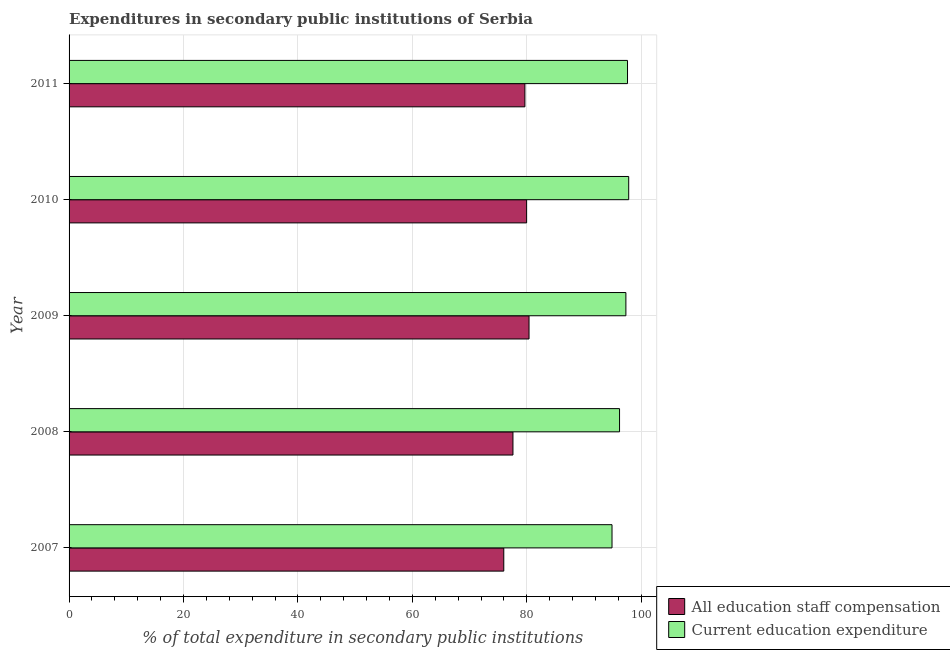How many different coloured bars are there?
Give a very brief answer. 2. How many groups of bars are there?
Ensure brevity in your answer.  5. Are the number of bars on each tick of the Y-axis equal?
Provide a succinct answer. Yes. How many bars are there on the 1st tick from the top?
Provide a short and direct response. 2. How many bars are there on the 4th tick from the bottom?
Offer a terse response. 2. What is the label of the 3rd group of bars from the top?
Offer a very short reply. 2009. What is the expenditure in education in 2011?
Make the answer very short. 97.61. Across all years, what is the maximum expenditure in education?
Provide a succinct answer. 97.81. Across all years, what is the minimum expenditure in education?
Ensure brevity in your answer.  94.9. In which year was the expenditure in education maximum?
Make the answer very short. 2010. What is the total expenditure in education in the graph?
Provide a short and direct response. 483.86. What is the difference between the expenditure in education in 2007 and that in 2008?
Your answer should be compact. -1.32. What is the difference between the expenditure in education in 2008 and the expenditure in staff compensation in 2009?
Your answer should be very brief. 15.82. What is the average expenditure in staff compensation per year?
Offer a terse response. 78.72. In the year 2008, what is the difference between the expenditure in education and expenditure in staff compensation?
Offer a very short reply. 18.63. What is the ratio of the expenditure in education in 2008 to that in 2009?
Your answer should be compact. 0.99. Is the expenditure in staff compensation in 2007 less than that in 2011?
Your answer should be very brief. Yes. Is the difference between the expenditure in staff compensation in 2007 and 2010 greater than the difference between the expenditure in education in 2007 and 2010?
Provide a short and direct response. No. What is the difference between the highest and the second highest expenditure in education?
Offer a terse response. 0.21. What is the difference between the highest and the lowest expenditure in staff compensation?
Make the answer very short. 4.41. What does the 2nd bar from the top in 2007 represents?
Keep it short and to the point. All education staff compensation. What does the 1st bar from the bottom in 2010 represents?
Offer a very short reply. All education staff compensation. Are all the bars in the graph horizontal?
Offer a terse response. Yes. What is the difference between two consecutive major ticks on the X-axis?
Keep it short and to the point. 20. Are the values on the major ticks of X-axis written in scientific E-notation?
Ensure brevity in your answer.  No. Does the graph contain any zero values?
Give a very brief answer. No. Where does the legend appear in the graph?
Your response must be concise. Bottom right. How are the legend labels stacked?
Your answer should be compact. Vertical. What is the title of the graph?
Give a very brief answer. Expenditures in secondary public institutions of Serbia. What is the label or title of the X-axis?
Your response must be concise. % of total expenditure in secondary public institutions. What is the % of total expenditure in secondary public institutions of All education staff compensation in 2007?
Ensure brevity in your answer.  75.98. What is the % of total expenditure in secondary public institutions of Current education expenditure in 2007?
Give a very brief answer. 94.9. What is the % of total expenditure in secondary public institutions in All education staff compensation in 2008?
Give a very brief answer. 77.58. What is the % of total expenditure in secondary public institutions of Current education expenditure in 2008?
Ensure brevity in your answer.  96.22. What is the % of total expenditure in secondary public institutions in All education staff compensation in 2009?
Offer a very short reply. 80.39. What is the % of total expenditure in secondary public institutions in Current education expenditure in 2009?
Give a very brief answer. 97.32. What is the % of total expenditure in secondary public institutions in All education staff compensation in 2010?
Keep it short and to the point. 79.97. What is the % of total expenditure in secondary public institutions of Current education expenditure in 2010?
Keep it short and to the point. 97.81. What is the % of total expenditure in secondary public institutions in All education staff compensation in 2011?
Give a very brief answer. 79.67. What is the % of total expenditure in secondary public institutions in Current education expenditure in 2011?
Keep it short and to the point. 97.61. Across all years, what is the maximum % of total expenditure in secondary public institutions of All education staff compensation?
Give a very brief answer. 80.39. Across all years, what is the maximum % of total expenditure in secondary public institutions in Current education expenditure?
Offer a very short reply. 97.81. Across all years, what is the minimum % of total expenditure in secondary public institutions of All education staff compensation?
Offer a terse response. 75.98. Across all years, what is the minimum % of total expenditure in secondary public institutions in Current education expenditure?
Ensure brevity in your answer.  94.9. What is the total % of total expenditure in secondary public institutions in All education staff compensation in the graph?
Keep it short and to the point. 393.61. What is the total % of total expenditure in secondary public institutions in Current education expenditure in the graph?
Your answer should be very brief. 483.86. What is the difference between the % of total expenditure in secondary public institutions of All education staff compensation in 2007 and that in 2008?
Your response must be concise. -1.6. What is the difference between the % of total expenditure in secondary public institutions in Current education expenditure in 2007 and that in 2008?
Keep it short and to the point. -1.32. What is the difference between the % of total expenditure in secondary public institutions in All education staff compensation in 2007 and that in 2009?
Provide a succinct answer. -4.41. What is the difference between the % of total expenditure in secondary public institutions of Current education expenditure in 2007 and that in 2009?
Give a very brief answer. -2.42. What is the difference between the % of total expenditure in secondary public institutions in All education staff compensation in 2007 and that in 2010?
Ensure brevity in your answer.  -3.99. What is the difference between the % of total expenditure in secondary public institutions of Current education expenditure in 2007 and that in 2010?
Offer a terse response. -2.92. What is the difference between the % of total expenditure in secondary public institutions of All education staff compensation in 2007 and that in 2011?
Provide a succinct answer. -3.69. What is the difference between the % of total expenditure in secondary public institutions of Current education expenditure in 2007 and that in 2011?
Your answer should be very brief. -2.71. What is the difference between the % of total expenditure in secondary public institutions of All education staff compensation in 2008 and that in 2009?
Offer a terse response. -2.81. What is the difference between the % of total expenditure in secondary public institutions in Current education expenditure in 2008 and that in 2009?
Your answer should be compact. -1.11. What is the difference between the % of total expenditure in secondary public institutions in All education staff compensation in 2008 and that in 2010?
Keep it short and to the point. -2.39. What is the difference between the % of total expenditure in secondary public institutions in Current education expenditure in 2008 and that in 2010?
Make the answer very short. -1.6. What is the difference between the % of total expenditure in secondary public institutions in All education staff compensation in 2008 and that in 2011?
Make the answer very short. -2.09. What is the difference between the % of total expenditure in secondary public institutions in Current education expenditure in 2008 and that in 2011?
Keep it short and to the point. -1.39. What is the difference between the % of total expenditure in secondary public institutions in All education staff compensation in 2009 and that in 2010?
Keep it short and to the point. 0.42. What is the difference between the % of total expenditure in secondary public institutions in Current education expenditure in 2009 and that in 2010?
Ensure brevity in your answer.  -0.49. What is the difference between the % of total expenditure in secondary public institutions of All education staff compensation in 2009 and that in 2011?
Make the answer very short. 0.72. What is the difference between the % of total expenditure in secondary public institutions in Current education expenditure in 2009 and that in 2011?
Make the answer very short. -0.29. What is the difference between the % of total expenditure in secondary public institutions in All education staff compensation in 2010 and that in 2011?
Your answer should be very brief. 0.3. What is the difference between the % of total expenditure in secondary public institutions of Current education expenditure in 2010 and that in 2011?
Your response must be concise. 0.21. What is the difference between the % of total expenditure in secondary public institutions of All education staff compensation in 2007 and the % of total expenditure in secondary public institutions of Current education expenditure in 2008?
Give a very brief answer. -20.23. What is the difference between the % of total expenditure in secondary public institutions of All education staff compensation in 2007 and the % of total expenditure in secondary public institutions of Current education expenditure in 2009?
Your answer should be compact. -21.34. What is the difference between the % of total expenditure in secondary public institutions of All education staff compensation in 2007 and the % of total expenditure in secondary public institutions of Current education expenditure in 2010?
Provide a succinct answer. -21.83. What is the difference between the % of total expenditure in secondary public institutions of All education staff compensation in 2007 and the % of total expenditure in secondary public institutions of Current education expenditure in 2011?
Make the answer very short. -21.63. What is the difference between the % of total expenditure in secondary public institutions in All education staff compensation in 2008 and the % of total expenditure in secondary public institutions in Current education expenditure in 2009?
Give a very brief answer. -19.74. What is the difference between the % of total expenditure in secondary public institutions of All education staff compensation in 2008 and the % of total expenditure in secondary public institutions of Current education expenditure in 2010?
Give a very brief answer. -20.23. What is the difference between the % of total expenditure in secondary public institutions of All education staff compensation in 2008 and the % of total expenditure in secondary public institutions of Current education expenditure in 2011?
Provide a succinct answer. -20.03. What is the difference between the % of total expenditure in secondary public institutions in All education staff compensation in 2009 and the % of total expenditure in secondary public institutions in Current education expenditure in 2010?
Keep it short and to the point. -17.42. What is the difference between the % of total expenditure in secondary public institutions in All education staff compensation in 2009 and the % of total expenditure in secondary public institutions in Current education expenditure in 2011?
Your answer should be compact. -17.21. What is the difference between the % of total expenditure in secondary public institutions of All education staff compensation in 2010 and the % of total expenditure in secondary public institutions of Current education expenditure in 2011?
Your response must be concise. -17.64. What is the average % of total expenditure in secondary public institutions in All education staff compensation per year?
Your answer should be very brief. 78.72. What is the average % of total expenditure in secondary public institutions in Current education expenditure per year?
Give a very brief answer. 96.77. In the year 2007, what is the difference between the % of total expenditure in secondary public institutions in All education staff compensation and % of total expenditure in secondary public institutions in Current education expenditure?
Make the answer very short. -18.92. In the year 2008, what is the difference between the % of total expenditure in secondary public institutions in All education staff compensation and % of total expenditure in secondary public institutions in Current education expenditure?
Offer a very short reply. -18.63. In the year 2009, what is the difference between the % of total expenditure in secondary public institutions in All education staff compensation and % of total expenditure in secondary public institutions in Current education expenditure?
Provide a short and direct response. -16.93. In the year 2010, what is the difference between the % of total expenditure in secondary public institutions of All education staff compensation and % of total expenditure in secondary public institutions of Current education expenditure?
Provide a short and direct response. -17.84. In the year 2011, what is the difference between the % of total expenditure in secondary public institutions in All education staff compensation and % of total expenditure in secondary public institutions in Current education expenditure?
Keep it short and to the point. -17.93. What is the ratio of the % of total expenditure in secondary public institutions in All education staff compensation in 2007 to that in 2008?
Provide a short and direct response. 0.98. What is the ratio of the % of total expenditure in secondary public institutions in Current education expenditure in 2007 to that in 2008?
Your response must be concise. 0.99. What is the ratio of the % of total expenditure in secondary public institutions in All education staff compensation in 2007 to that in 2009?
Offer a very short reply. 0.95. What is the ratio of the % of total expenditure in secondary public institutions of Current education expenditure in 2007 to that in 2009?
Give a very brief answer. 0.98. What is the ratio of the % of total expenditure in secondary public institutions in All education staff compensation in 2007 to that in 2010?
Offer a terse response. 0.95. What is the ratio of the % of total expenditure in secondary public institutions in Current education expenditure in 2007 to that in 2010?
Your response must be concise. 0.97. What is the ratio of the % of total expenditure in secondary public institutions of All education staff compensation in 2007 to that in 2011?
Ensure brevity in your answer.  0.95. What is the ratio of the % of total expenditure in secondary public institutions in Current education expenditure in 2007 to that in 2011?
Give a very brief answer. 0.97. What is the ratio of the % of total expenditure in secondary public institutions in All education staff compensation in 2008 to that in 2010?
Ensure brevity in your answer.  0.97. What is the ratio of the % of total expenditure in secondary public institutions of Current education expenditure in 2008 to that in 2010?
Provide a short and direct response. 0.98. What is the ratio of the % of total expenditure in secondary public institutions of All education staff compensation in 2008 to that in 2011?
Keep it short and to the point. 0.97. What is the ratio of the % of total expenditure in secondary public institutions of Current education expenditure in 2008 to that in 2011?
Offer a terse response. 0.99. What is the ratio of the % of total expenditure in secondary public institutions in All education staff compensation in 2009 to that in 2010?
Offer a terse response. 1.01. What is the ratio of the % of total expenditure in secondary public institutions in Current education expenditure in 2009 to that in 2011?
Provide a succinct answer. 1. What is the ratio of the % of total expenditure in secondary public institutions in All education staff compensation in 2010 to that in 2011?
Your answer should be very brief. 1. What is the difference between the highest and the second highest % of total expenditure in secondary public institutions of All education staff compensation?
Ensure brevity in your answer.  0.42. What is the difference between the highest and the second highest % of total expenditure in secondary public institutions of Current education expenditure?
Give a very brief answer. 0.21. What is the difference between the highest and the lowest % of total expenditure in secondary public institutions in All education staff compensation?
Offer a terse response. 4.41. What is the difference between the highest and the lowest % of total expenditure in secondary public institutions in Current education expenditure?
Make the answer very short. 2.92. 